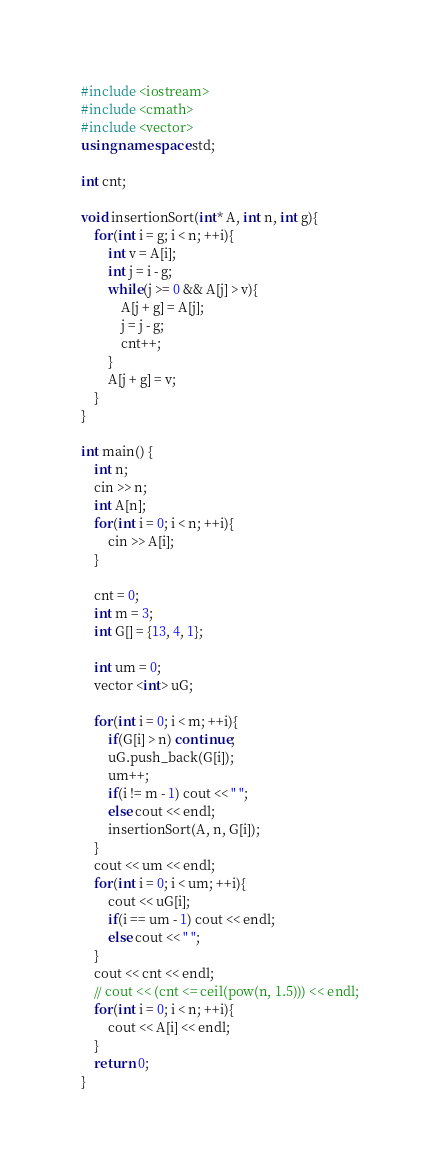Convert code to text. <code><loc_0><loc_0><loc_500><loc_500><_C++_>#include <iostream>
#include <cmath>
#include <vector>
using namespace std;

int cnt;

void insertionSort(int* A, int n, int g){
	for(int i = g; i < n; ++i){
		int v = A[i];
		int j = i - g;
		while(j >= 0 && A[j] > v){
			A[j + g] = A[j];
			j = j - g;
			cnt++;
		}
		A[j + g] = v;
	}
}

int main() {
	int n;
	cin >> n;
	int A[n];
	for(int i = 0; i < n; ++i){
		cin >> A[i];
	}
	
	cnt = 0;
	int m = 3;
	int G[] = {13, 4, 1};
	
	int um = 0;
	vector <int> uG;
	
	for(int i = 0; i < m; ++i){
		if(G[i] > n) continue;
		uG.push_back(G[i]);
		um++;
		if(i != m - 1) cout << " ";
		else cout << endl;
		insertionSort(A, n, G[i]);
	}
	cout << um << endl;
	for(int i = 0; i < um; ++i){
		cout << uG[i];
		if(i == um - 1) cout << endl;
		else cout << " ";
	}
	cout << cnt << endl;
	// cout << (cnt <= ceil(pow(n, 1.5))) << endl;
	for(int i = 0; i < n; ++i){
		cout << A[i] << endl;
	}
	return 0;
}</code> 